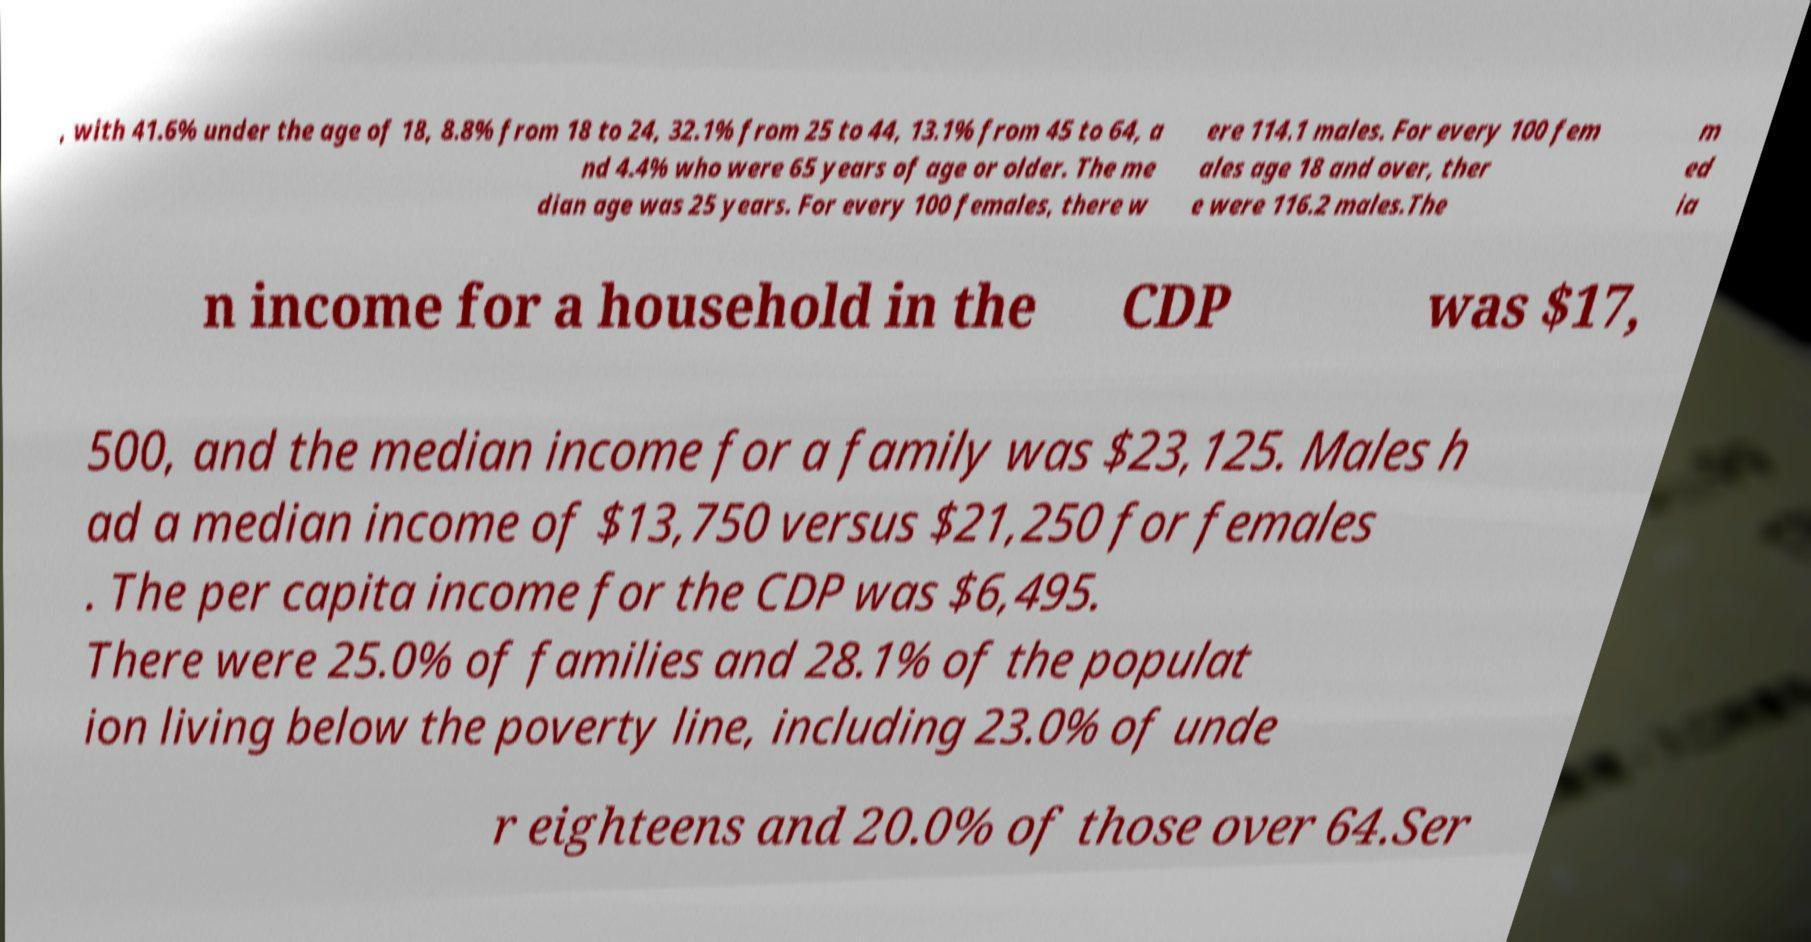For documentation purposes, I need the text within this image transcribed. Could you provide that? , with 41.6% under the age of 18, 8.8% from 18 to 24, 32.1% from 25 to 44, 13.1% from 45 to 64, a nd 4.4% who were 65 years of age or older. The me dian age was 25 years. For every 100 females, there w ere 114.1 males. For every 100 fem ales age 18 and over, ther e were 116.2 males.The m ed ia n income for a household in the CDP was $17, 500, and the median income for a family was $23,125. Males h ad a median income of $13,750 versus $21,250 for females . The per capita income for the CDP was $6,495. There were 25.0% of families and 28.1% of the populat ion living below the poverty line, including 23.0% of unde r eighteens and 20.0% of those over 64.Ser 